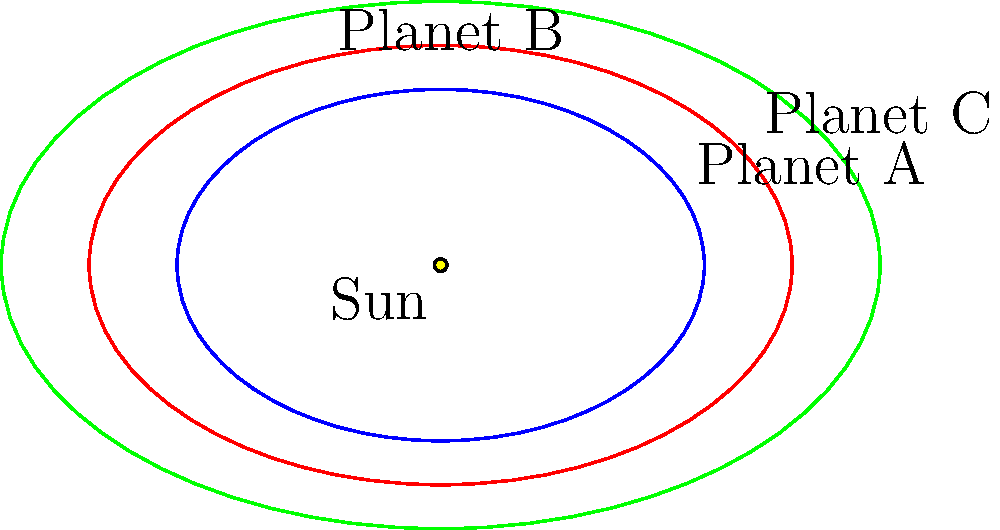In the context of implementing AI for analyzing planetary orbits in the justice system, consider the elliptical orbits of three planets (A, B, and C) around the Sun, as shown in the diagram. If we define the eccentricity of an ellipse as $e = \sqrt{1 - \frac{b^2}{a^2}}$, where $a$ is the semi-major axis and $b$ is the semi-minor axis, which planet has the highest eccentricity and thus the most elongated orbit? To determine which planet has the highest eccentricity, we need to calculate the eccentricity for each planet using the formula $e = \sqrt{1 - \frac{b^2}{a^2}}$. Let's go through this step-by-step:

1. For Planet A:
   $a_1 = 3$, $b_1 = 2$
   $e_A = \sqrt{1 - \frac{2^2}{3^2}} = \sqrt{1 - \frac{4}{9}} = \sqrt{\frac{5}{9}} \approx 0.745$

2. For Planet B:
   $a_2 = 4$, $b_2 = 2.5$
   $e_B = \sqrt{1 - \frac{2.5^2}{4^2}} = \sqrt{1 - \frac{6.25}{16}} = \sqrt{\frac{9.75}{16}} \approx 0.780$

3. For Planet C:
   $a_3 = 5$, $b_3 = 3$
   $e_C = \sqrt{1 - \frac{3^2}{5^2}} = \sqrt{1 - \frac{9}{25}} = \sqrt{\frac{16}{25}} = 0.800$

Comparing the eccentricities:
$e_A \approx 0.745$
$e_B \approx 0.780$
$e_C = 0.800$

Planet C has the highest eccentricity, which means it has the most elongated orbit among the three planets.
Answer: Planet C 